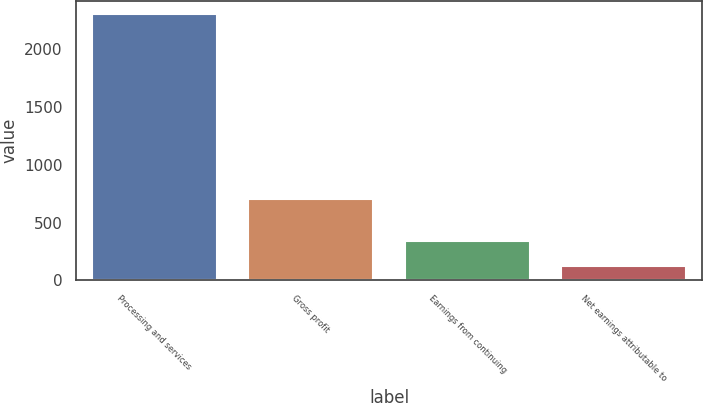Convert chart to OTSL. <chart><loc_0><loc_0><loc_500><loc_500><bar_chart><fcel>Processing and services<fcel>Gross profit<fcel>Earnings from continuing<fcel>Net earnings attributable to<nl><fcel>2305<fcel>705<fcel>339.4<fcel>121<nl></chart> 